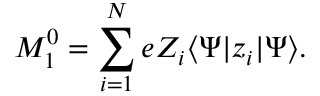Convert formula to latex. <formula><loc_0><loc_0><loc_500><loc_500>M _ { 1 } ^ { 0 } = \sum _ { i = 1 } ^ { N } e Z _ { i } \langle \Psi | z _ { i } | \Psi \rangle .</formula> 